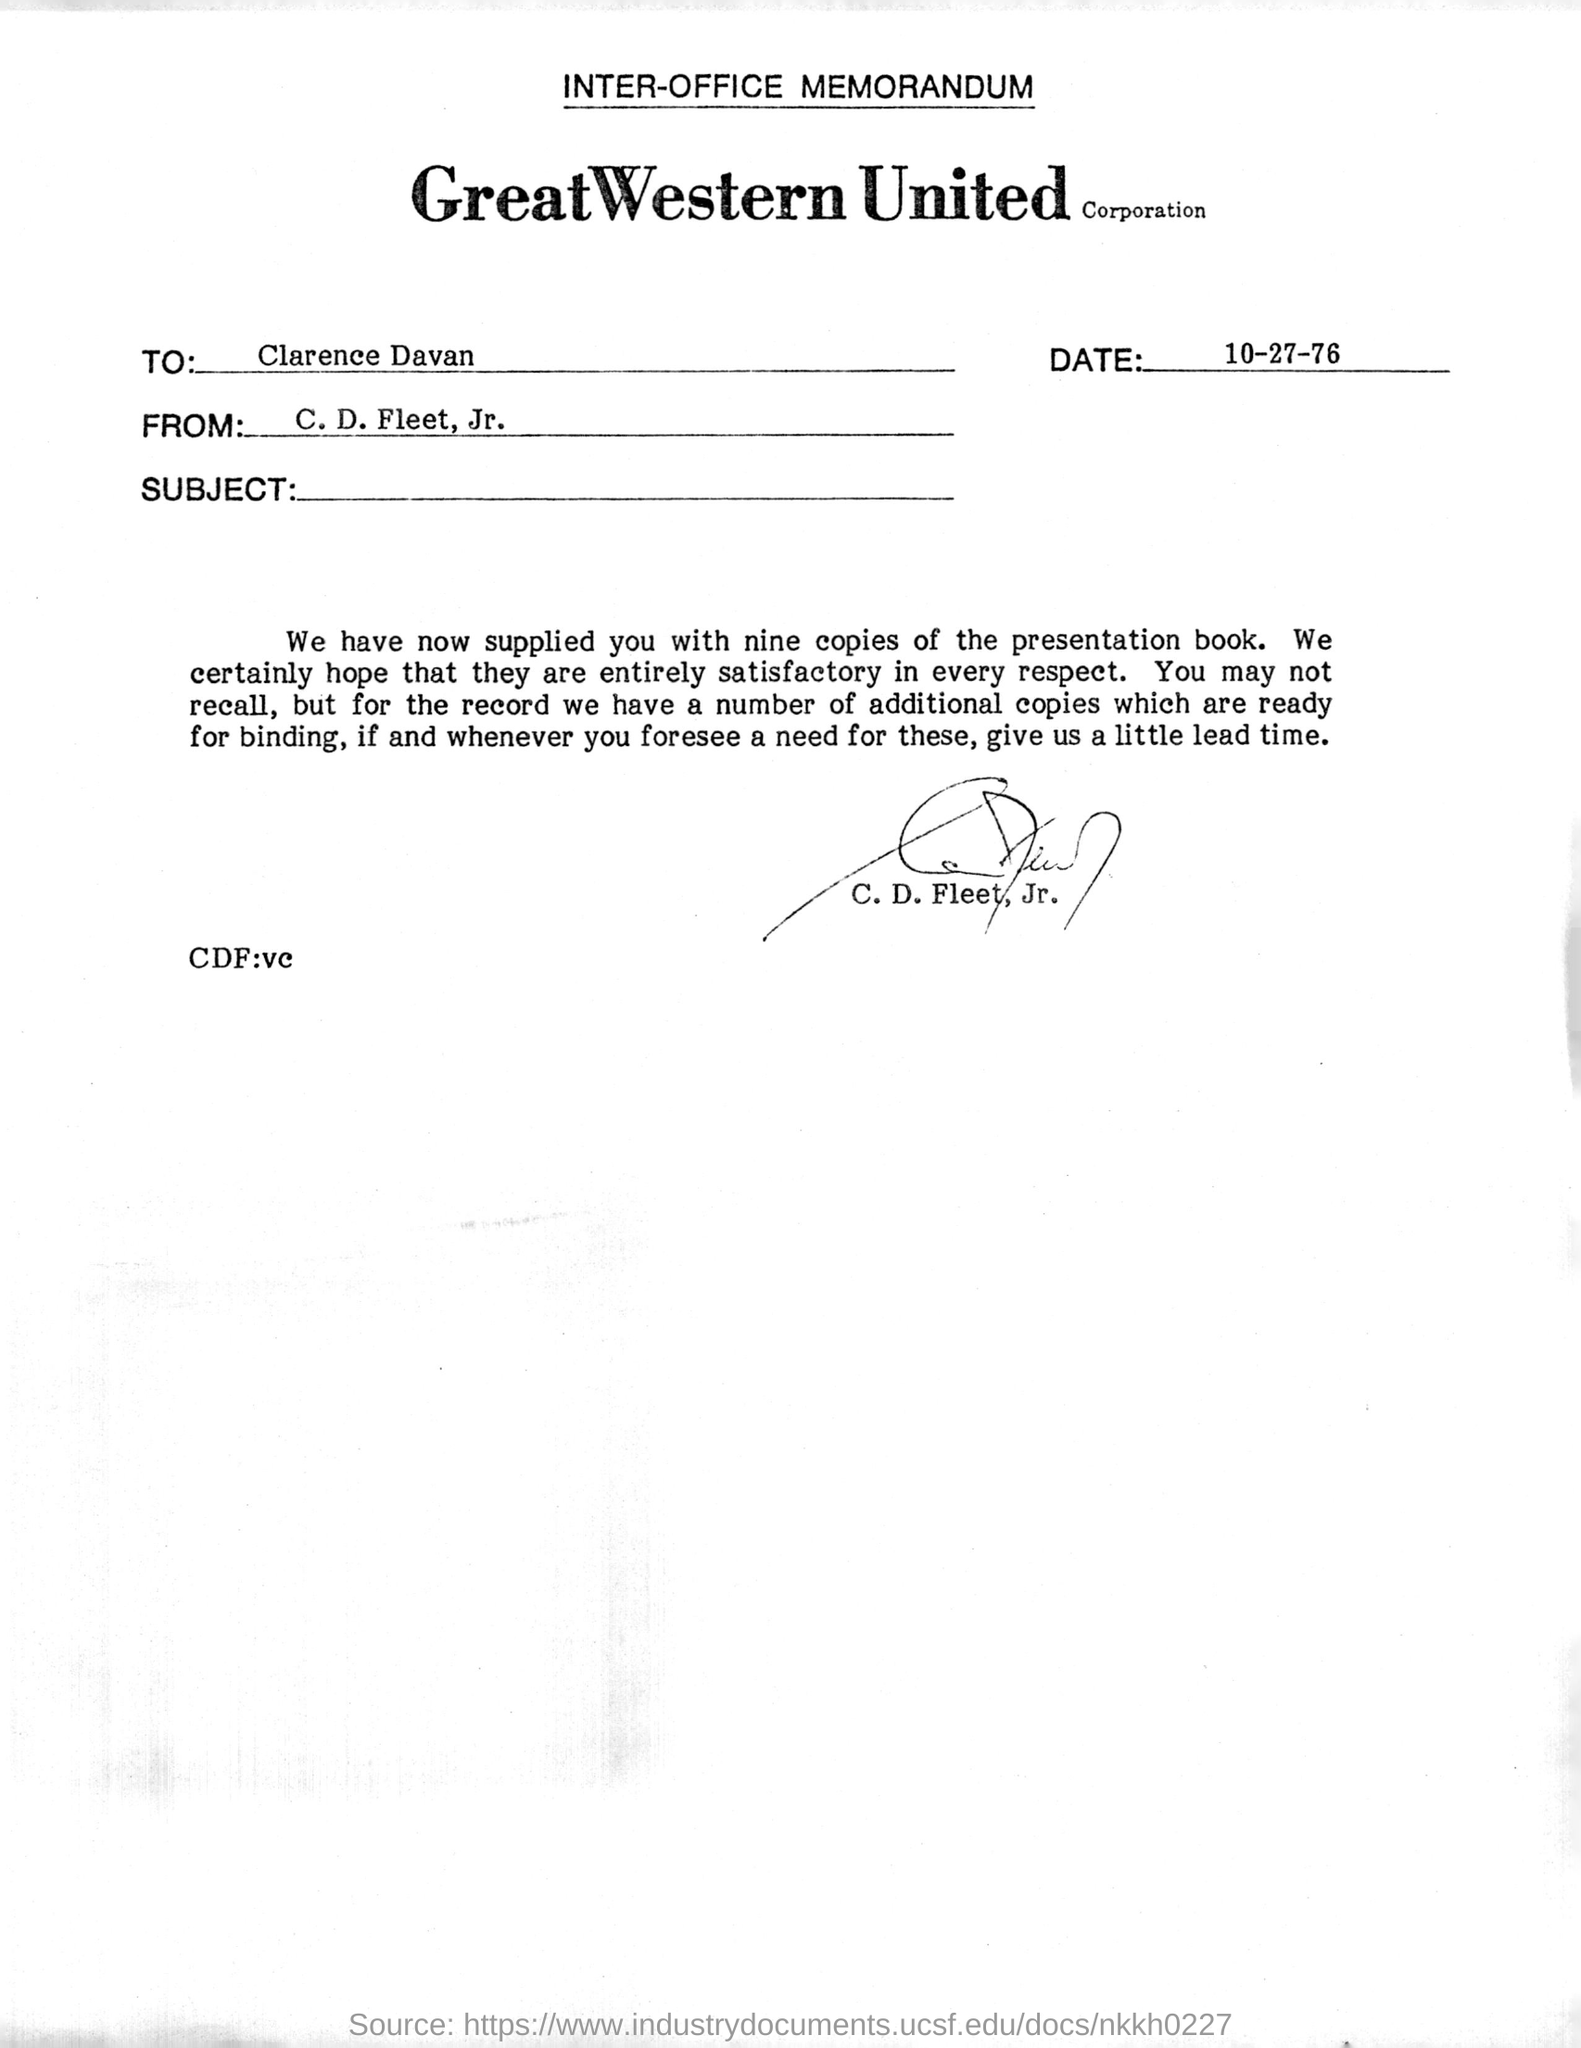Draw attention to some important aspects in this diagram. The recipient of the memorandum is Clarence Davan. This is an inter-office memorandum. The sender of this memorandum is C. D. Fleet, Jr. The memorandum was signed by C. D. Fleet, Jr. The memorandum is dated October 27, 1976. 